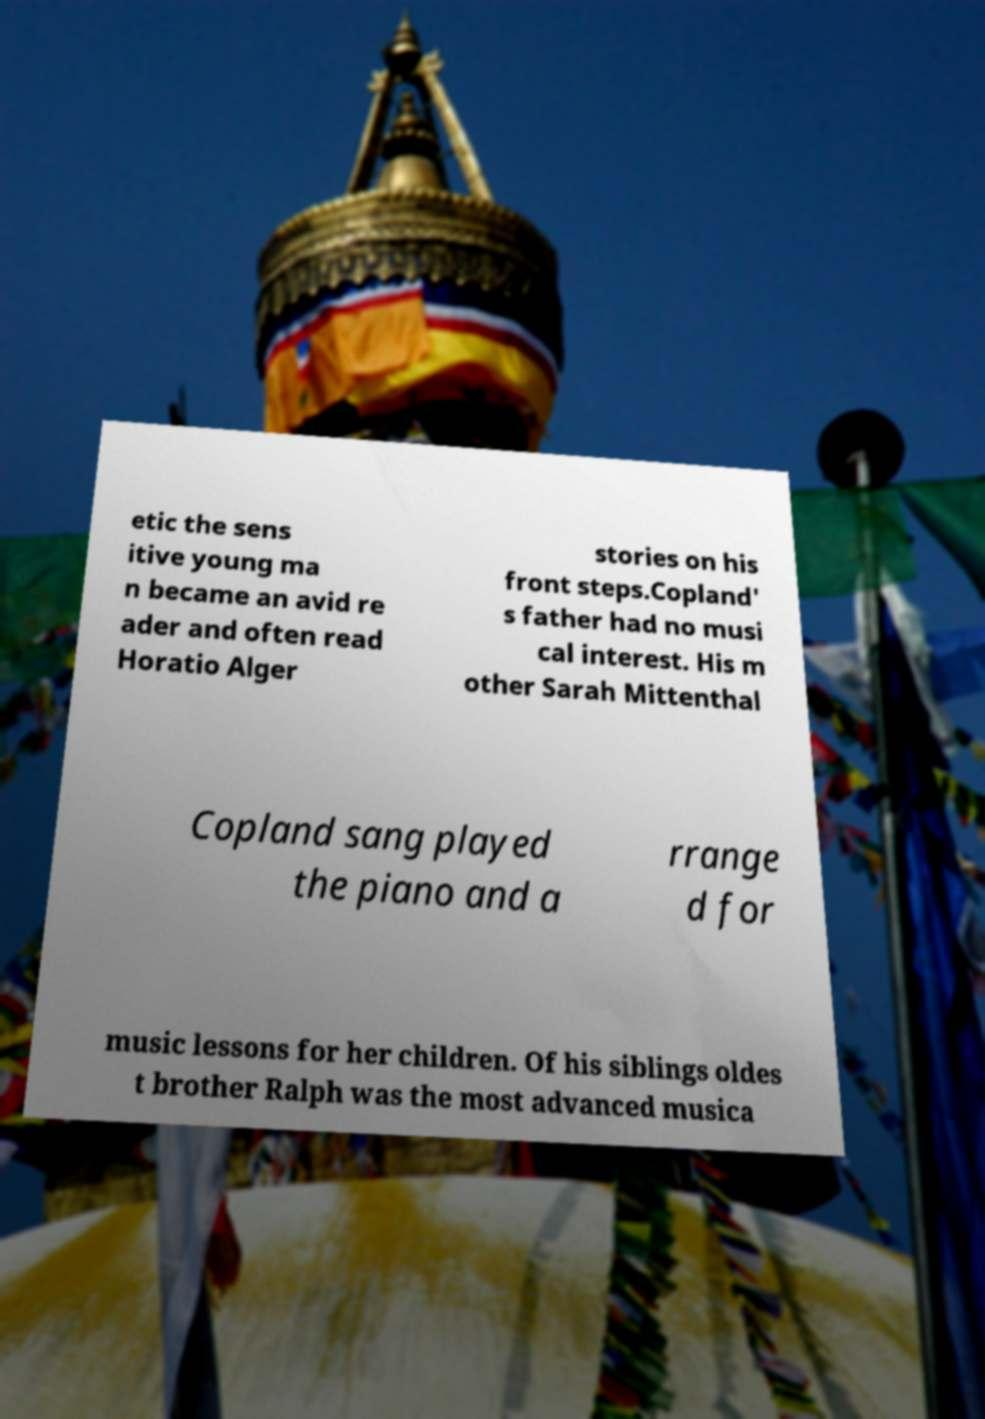I need the written content from this picture converted into text. Can you do that? etic the sens itive young ma n became an avid re ader and often read Horatio Alger stories on his front steps.Copland' s father had no musi cal interest. His m other Sarah Mittenthal Copland sang played the piano and a rrange d for music lessons for her children. Of his siblings oldes t brother Ralph was the most advanced musica 